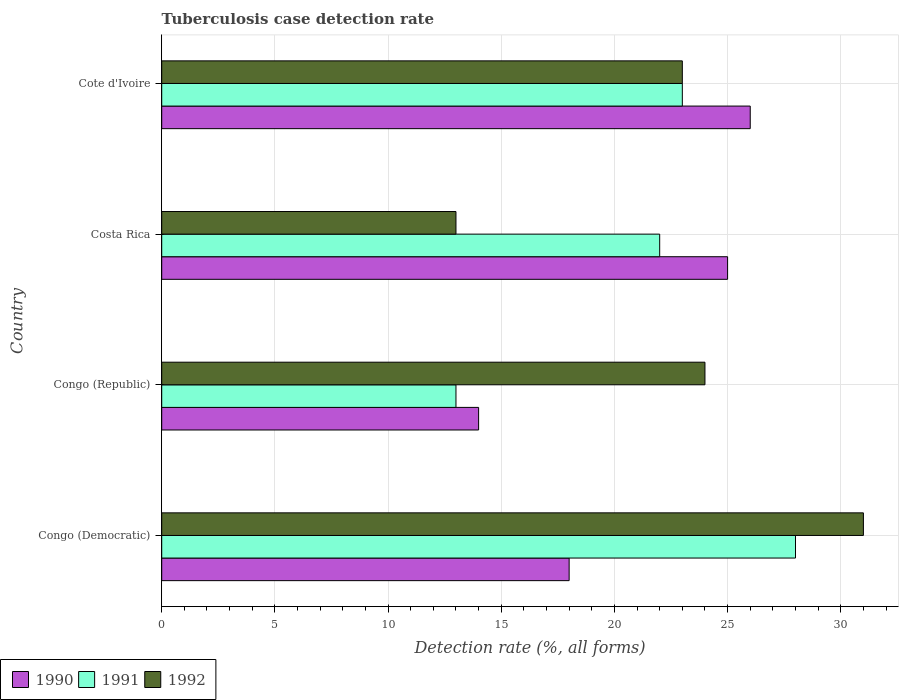How many groups of bars are there?
Provide a succinct answer. 4. What is the label of the 3rd group of bars from the top?
Offer a terse response. Congo (Republic). What is the tuberculosis case detection rate in in 1990 in Costa Rica?
Give a very brief answer. 25. Across all countries, what is the minimum tuberculosis case detection rate in in 1992?
Your response must be concise. 13. In which country was the tuberculosis case detection rate in in 1990 maximum?
Make the answer very short. Cote d'Ivoire. In which country was the tuberculosis case detection rate in in 1991 minimum?
Provide a succinct answer. Congo (Republic). What is the difference between the tuberculosis case detection rate in in 1991 in Congo (Democratic) and that in Cote d'Ivoire?
Provide a short and direct response. 5. What is the difference between the tuberculosis case detection rate in in 1992 in Cote d'Ivoire and the tuberculosis case detection rate in in 1990 in Congo (Democratic)?
Keep it short and to the point. 5. What is the average tuberculosis case detection rate in in 1992 per country?
Your response must be concise. 22.75. What is the difference between the tuberculosis case detection rate in in 1991 and tuberculosis case detection rate in in 1990 in Congo (Republic)?
Your answer should be very brief. -1. In how many countries, is the tuberculosis case detection rate in in 1992 greater than 27 %?
Give a very brief answer. 1. What is the ratio of the tuberculosis case detection rate in in 1990 in Congo (Republic) to that in Cote d'Ivoire?
Your answer should be very brief. 0.54. Is the tuberculosis case detection rate in in 1990 in Congo (Democratic) less than that in Congo (Republic)?
Keep it short and to the point. No. Is the difference between the tuberculosis case detection rate in in 1991 in Congo (Democratic) and Cote d'Ivoire greater than the difference between the tuberculosis case detection rate in in 1990 in Congo (Democratic) and Cote d'Ivoire?
Provide a short and direct response. Yes. In how many countries, is the tuberculosis case detection rate in in 1990 greater than the average tuberculosis case detection rate in in 1990 taken over all countries?
Ensure brevity in your answer.  2. Is the sum of the tuberculosis case detection rate in in 1991 in Costa Rica and Cote d'Ivoire greater than the maximum tuberculosis case detection rate in in 1990 across all countries?
Offer a terse response. Yes. What does the 2nd bar from the top in Cote d'Ivoire represents?
Make the answer very short. 1991. Is it the case that in every country, the sum of the tuberculosis case detection rate in in 1992 and tuberculosis case detection rate in in 1990 is greater than the tuberculosis case detection rate in in 1991?
Keep it short and to the point. Yes. How many bars are there?
Provide a short and direct response. 12. Are all the bars in the graph horizontal?
Your answer should be very brief. Yes. What is the difference between two consecutive major ticks on the X-axis?
Offer a terse response. 5. Are the values on the major ticks of X-axis written in scientific E-notation?
Your answer should be very brief. No. How are the legend labels stacked?
Your answer should be very brief. Horizontal. What is the title of the graph?
Your answer should be compact. Tuberculosis case detection rate. What is the label or title of the X-axis?
Your response must be concise. Detection rate (%, all forms). What is the Detection rate (%, all forms) of 1991 in Congo (Democratic)?
Ensure brevity in your answer.  28. What is the Detection rate (%, all forms) of 1992 in Congo (Democratic)?
Your response must be concise. 31. What is the Detection rate (%, all forms) in 1991 in Congo (Republic)?
Make the answer very short. 13. What is the Detection rate (%, all forms) in 1990 in Cote d'Ivoire?
Your answer should be very brief. 26. What is the Detection rate (%, all forms) of 1992 in Cote d'Ivoire?
Give a very brief answer. 23. Across all countries, what is the maximum Detection rate (%, all forms) of 1991?
Provide a succinct answer. 28. Across all countries, what is the minimum Detection rate (%, all forms) of 1990?
Offer a terse response. 14. What is the total Detection rate (%, all forms) in 1990 in the graph?
Provide a succinct answer. 83. What is the total Detection rate (%, all forms) in 1991 in the graph?
Your answer should be compact. 86. What is the total Detection rate (%, all forms) in 1992 in the graph?
Make the answer very short. 91. What is the difference between the Detection rate (%, all forms) in 1990 in Congo (Democratic) and that in Congo (Republic)?
Provide a succinct answer. 4. What is the difference between the Detection rate (%, all forms) in 1991 in Congo (Democratic) and that in Congo (Republic)?
Give a very brief answer. 15. What is the difference between the Detection rate (%, all forms) of 1990 in Congo (Democratic) and that in Costa Rica?
Make the answer very short. -7. What is the difference between the Detection rate (%, all forms) of 1992 in Congo (Democratic) and that in Cote d'Ivoire?
Your answer should be very brief. 8. What is the difference between the Detection rate (%, all forms) in 1991 in Congo (Republic) and that in Cote d'Ivoire?
Offer a very short reply. -10. What is the difference between the Detection rate (%, all forms) in 1992 in Congo (Republic) and that in Cote d'Ivoire?
Give a very brief answer. 1. What is the difference between the Detection rate (%, all forms) in 1991 in Costa Rica and that in Cote d'Ivoire?
Your answer should be very brief. -1. What is the difference between the Detection rate (%, all forms) of 1992 in Costa Rica and that in Cote d'Ivoire?
Ensure brevity in your answer.  -10. What is the difference between the Detection rate (%, all forms) in 1990 in Congo (Democratic) and the Detection rate (%, all forms) in 1991 in Congo (Republic)?
Your answer should be very brief. 5. What is the difference between the Detection rate (%, all forms) of 1991 in Congo (Democratic) and the Detection rate (%, all forms) of 1992 in Congo (Republic)?
Provide a short and direct response. 4. What is the difference between the Detection rate (%, all forms) of 1990 in Congo (Democratic) and the Detection rate (%, all forms) of 1992 in Costa Rica?
Your response must be concise. 5. What is the difference between the Detection rate (%, all forms) in 1991 in Congo (Democratic) and the Detection rate (%, all forms) in 1992 in Costa Rica?
Provide a short and direct response. 15. What is the difference between the Detection rate (%, all forms) of 1990 in Congo (Democratic) and the Detection rate (%, all forms) of 1992 in Cote d'Ivoire?
Offer a very short reply. -5. What is the difference between the Detection rate (%, all forms) of 1991 in Congo (Democratic) and the Detection rate (%, all forms) of 1992 in Cote d'Ivoire?
Provide a short and direct response. 5. What is the difference between the Detection rate (%, all forms) in 1990 in Congo (Republic) and the Detection rate (%, all forms) in 1991 in Costa Rica?
Keep it short and to the point. -8. What is the difference between the Detection rate (%, all forms) of 1990 in Congo (Republic) and the Detection rate (%, all forms) of 1992 in Costa Rica?
Offer a very short reply. 1. What is the difference between the Detection rate (%, all forms) in 1991 in Congo (Republic) and the Detection rate (%, all forms) in 1992 in Costa Rica?
Provide a succinct answer. 0. What is the difference between the Detection rate (%, all forms) of 1990 in Congo (Republic) and the Detection rate (%, all forms) of 1991 in Cote d'Ivoire?
Keep it short and to the point. -9. What is the difference between the Detection rate (%, all forms) in 1990 in Congo (Republic) and the Detection rate (%, all forms) in 1992 in Cote d'Ivoire?
Your answer should be very brief. -9. What is the average Detection rate (%, all forms) of 1990 per country?
Keep it short and to the point. 20.75. What is the average Detection rate (%, all forms) of 1992 per country?
Make the answer very short. 22.75. What is the difference between the Detection rate (%, all forms) in 1990 and Detection rate (%, all forms) in 1991 in Congo (Democratic)?
Ensure brevity in your answer.  -10. What is the difference between the Detection rate (%, all forms) in 1990 and Detection rate (%, all forms) in 1992 in Congo (Democratic)?
Your answer should be compact. -13. What is the difference between the Detection rate (%, all forms) of 1991 and Detection rate (%, all forms) of 1992 in Congo (Democratic)?
Your response must be concise. -3. What is the difference between the Detection rate (%, all forms) in 1990 and Detection rate (%, all forms) in 1992 in Congo (Republic)?
Offer a terse response. -10. What is the difference between the Detection rate (%, all forms) in 1990 and Detection rate (%, all forms) in 1991 in Costa Rica?
Your answer should be compact. 3. What is the difference between the Detection rate (%, all forms) of 1991 and Detection rate (%, all forms) of 1992 in Costa Rica?
Your response must be concise. 9. What is the difference between the Detection rate (%, all forms) in 1990 and Detection rate (%, all forms) in 1991 in Cote d'Ivoire?
Make the answer very short. 3. What is the ratio of the Detection rate (%, all forms) of 1991 in Congo (Democratic) to that in Congo (Republic)?
Offer a very short reply. 2.15. What is the ratio of the Detection rate (%, all forms) in 1992 in Congo (Democratic) to that in Congo (Republic)?
Provide a short and direct response. 1.29. What is the ratio of the Detection rate (%, all forms) of 1990 in Congo (Democratic) to that in Costa Rica?
Your response must be concise. 0.72. What is the ratio of the Detection rate (%, all forms) in 1991 in Congo (Democratic) to that in Costa Rica?
Offer a terse response. 1.27. What is the ratio of the Detection rate (%, all forms) of 1992 in Congo (Democratic) to that in Costa Rica?
Keep it short and to the point. 2.38. What is the ratio of the Detection rate (%, all forms) of 1990 in Congo (Democratic) to that in Cote d'Ivoire?
Offer a terse response. 0.69. What is the ratio of the Detection rate (%, all forms) in 1991 in Congo (Democratic) to that in Cote d'Ivoire?
Keep it short and to the point. 1.22. What is the ratio of the Detection rate (%, all forms) of 1992 in Congo (Democratic) to that in Cote d'Ivoire?
Ensure brevity in your answer.  1.35. What is the ratio of the Detection rate (%, all forms) in 1990 in Congo (Republic) to that in Costa Rica?
Ensure brevity in your answer.  0.56. What is the ratio of the Detection rate (%, all forms) of 1991 in Congo (Republic) to that in Costa Rica?
Your response must be concise. 0.59. What is the ratio of the Detection rate (%, all forms) in 1992 in Congo (Republic) to that in Costa Rica?
Your answer should be very brief. 1.85. What is the ratio of the Detection rate (%, all forms) of 1990 in Congo (Republic) to that in Cote d'Ivoire?
Your answer should be very brief. 0.54. What is the ratio of the Detection rate (%, all forms) of 1991 in Congo (Republic) to that in Cote d'Ivoire?
Provide a short and direct response. 0.57. What is the ratio of the Detection rate (%, all forms) of 1992 in Congo (Republic) to that in Cote d'Ivoire?
Provide a succinct answer. 1.04. What is the ratio of the Detection rate (%, all forms) in 1990 in Costa Rica to that in Cote d'Ivoire?
Keep it short and to the point. 0.96. What is the ratio of the Detection rate (%, all forms) in 1991 in Costa Rica to that in Cote d'Ivoire?
Offer a very short reply. 0.96. What is the ratio of the Detection rate (%, all forms) in 1992 in Costa Rica to that in Cote d'Ivoire?
Your answer should be compact. 0.57. What is the difference between the highest and the second highest Detection rate (%, all forms) of 1990?
Offer a terse response. 1. What is the difference between the highest and the lowest Detection rate (%, all forms) of 1991?
Offer a terse response. 15. 